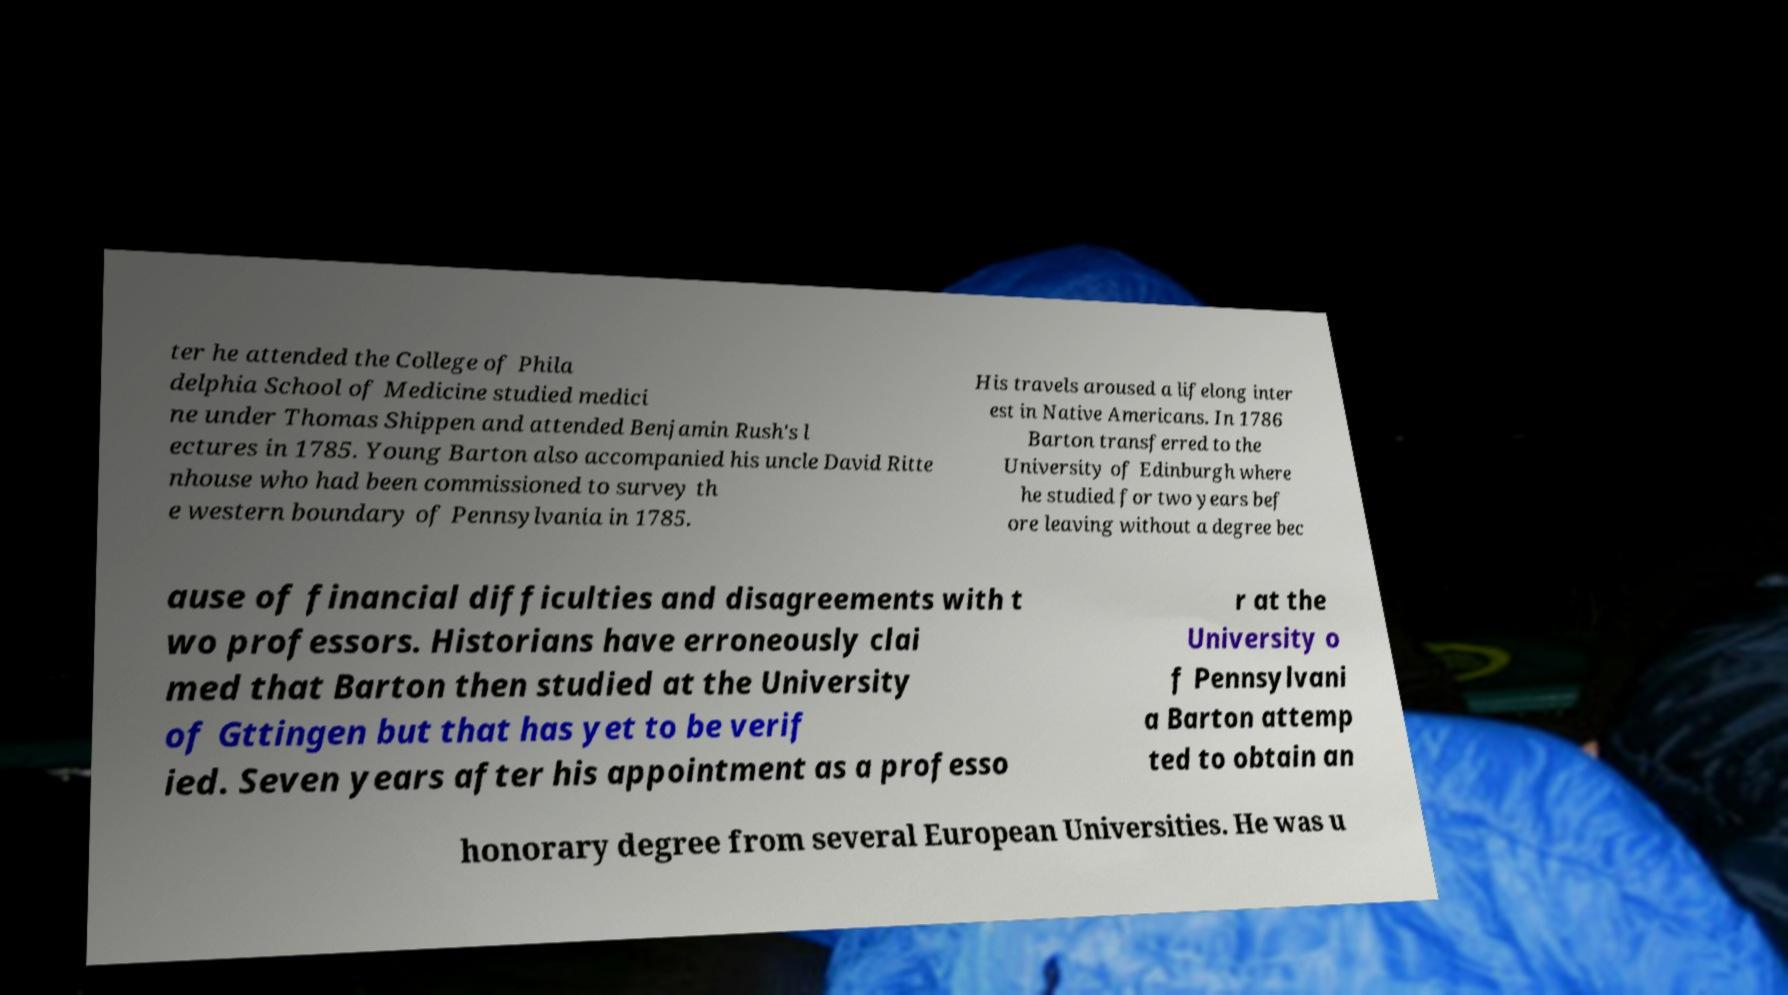Please identify and transcribe the text found in this image. ter he attended the College of Phila delphia School of Medicine studied medici ne under Thomas Shippen and attended Benjamin Rush's l ectures in 1785. Young Barton also accompanied his uncle David Ritte nhouse who had been commissioned to survey th e western boundary of Pennsylvania in 1785. His travels aroused a lifelong inter est in Native Americans. In 1786 Barton transferred to the University of Edinburgh where he studied for two years bef ore leaving without a degree bec ause of financial difficulties and disagreements with t wo professors. Historians have erroneously clai med that Barton then studied at the University of Gttingen but that has yet to be verif ied. Seven years after his appointment as a professo r at the University o f Pennsylvani a Barton attemp ted to obtain an honorary degree from several European Universities. He was u 